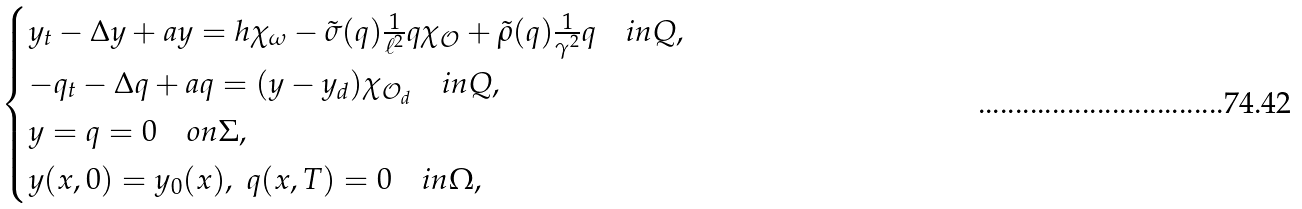Convert formula to latex. <formula><loc_0><loc_0><loc_500><loc_500>& \begin{cases} y _ { t } - \Delta y + a y = h \chi _ { \omega } - \tilde { \sigma } ( q ) \frac { 1 } { \ell ^ { 2 } } q \chi _ { \mathcal { O } } + \tilde { \rho } ( q ) \frac { 1 } { \gamma ^ { 2 } } q \quad i n Q , \\ - q _ { t } - \Delta q + a q = ( y - y _ { d } ) \chi _ { \mathcal { O } _ { d } } \quad i n Q , \\ y = q = 0 \quad o n \Sigma , \\ y ( x , 0 ) = y _ { 0 } ( x ) , \ q ( x , T ) = 0 \quad i n \Omega , \\ \end{cases}</formula> 